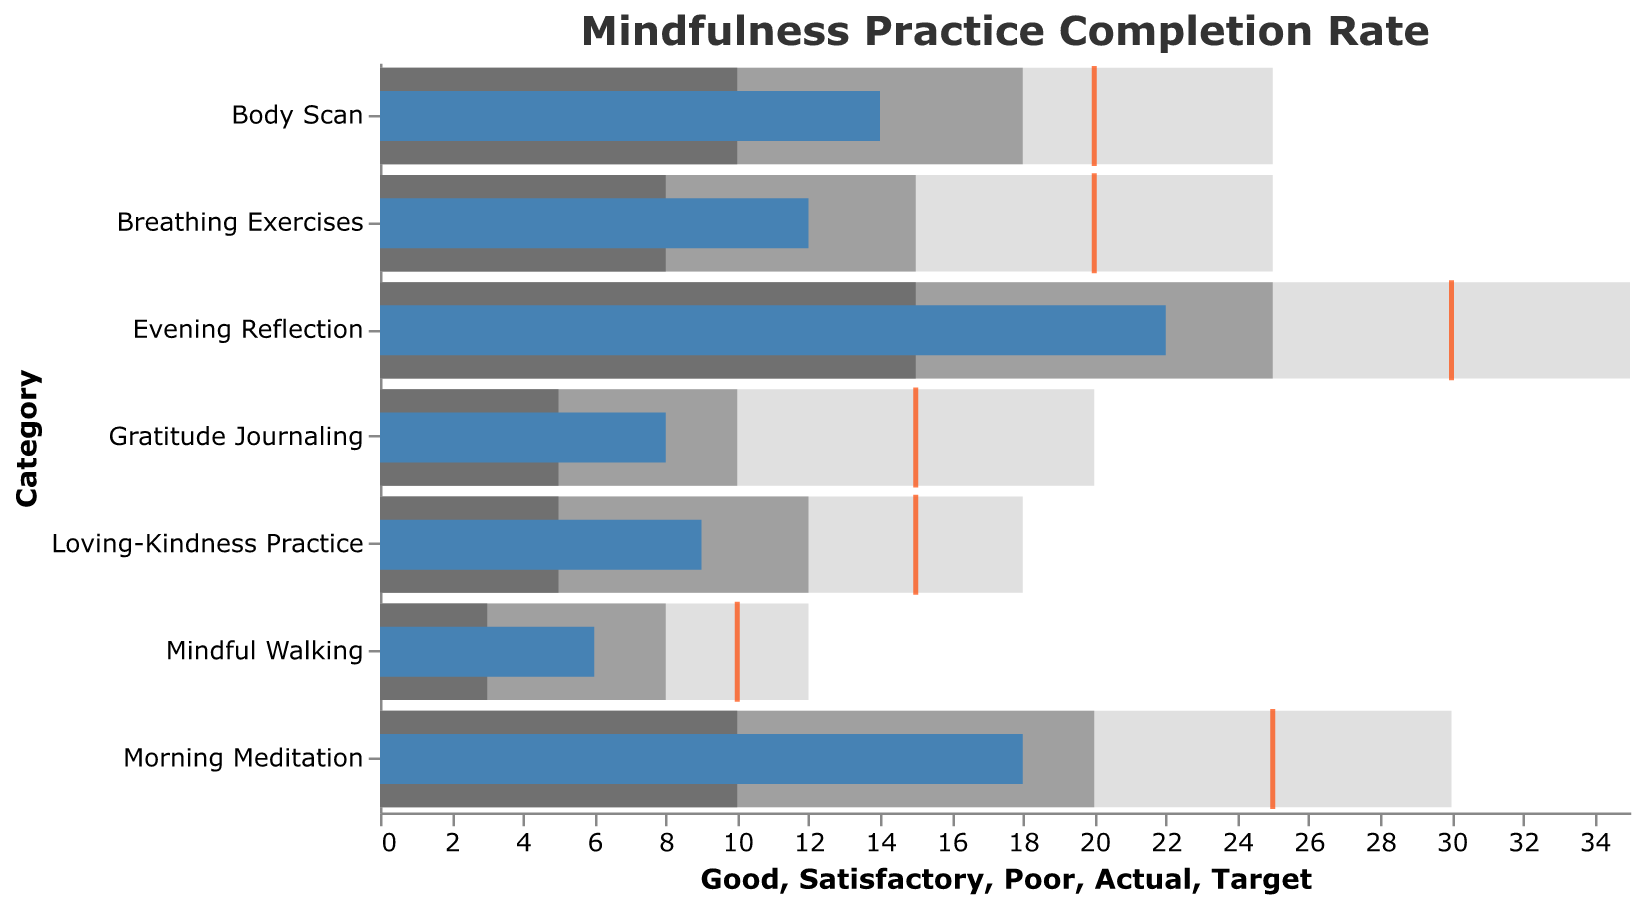What is the title of the figure? The title of the figure is identified at the top of the chart. It reads "Mindfulness Practice Completion Rate."
Answer: Mindfulness Practice Completion Rate What is the target completion rate for "Morning Meditation"? Looking at the target tick mark positioned above "Morning Meditation," it is at 25.
Answer: 25 Which mindfulness practice has the highest actual completion rate? Compare the heights of all the blue bars representing actual completion rates. "Evening Reflection" has the tallest bar.
Answer: Evening Reflection How does the actual completion rate for "Mindful Walking" compare to its target? The actual bar for "Mindful Walking" is at 6 while the target tick is at 10. Therefore, it is less than the target by 4.
Answer: Less by 4 What is the range defined as "Good" for "Evening Reflection"? Refer to the lightest gray bar for "Evening Reflection," It ranges from 15 to 35.
Answer: 15 to 35 Which mindfulness practices fall into the "Satisfactory" range? Identify the categories where the blue bars fall within the medium gray bars. These are "Morning Meditation," "Breathing Exercises," "Gratitude Journaling," "Body Scan," and "Loving-Kindness Practice."
Answer: Morning Meditation, Breathing Exercises, Gratitude Journaling, Body Scan, and Loving-Kindness Practice Compare the actual completion rates of "Gratitude Journaling" and "Loving-Kindness Practice." Which is higher? The actual completion rate of "Gratitude Journaling" is 8, and for "Loving-Kindness Practice," it is 9. Therefore, "Loving-Kindness Practice" is higher.
Answer: Loving-Kindness Practice How far is the actual completion of "Body Scan" from being considered "Good"? The "Good" range for "Body Scan" starts at 18. The actual completion rate is at 14, so it needs 4 more to reach "Good."
Answer: 4 Which mindfulness practices do not meet even the "Poor" range? Compare the actual blue bars against the darkest gray "Poor" ranges. "Mindful Walking" is below its poor range.
Answer: Mindful Walking What is the average target completion rate across all practices? Sum all the target values (25 + 30 + 20 + 15 + 20 + 10 + 15) = 135, then divide by the number of categories (7). 135/7 ≈ 19.3
Answer: 19.3 